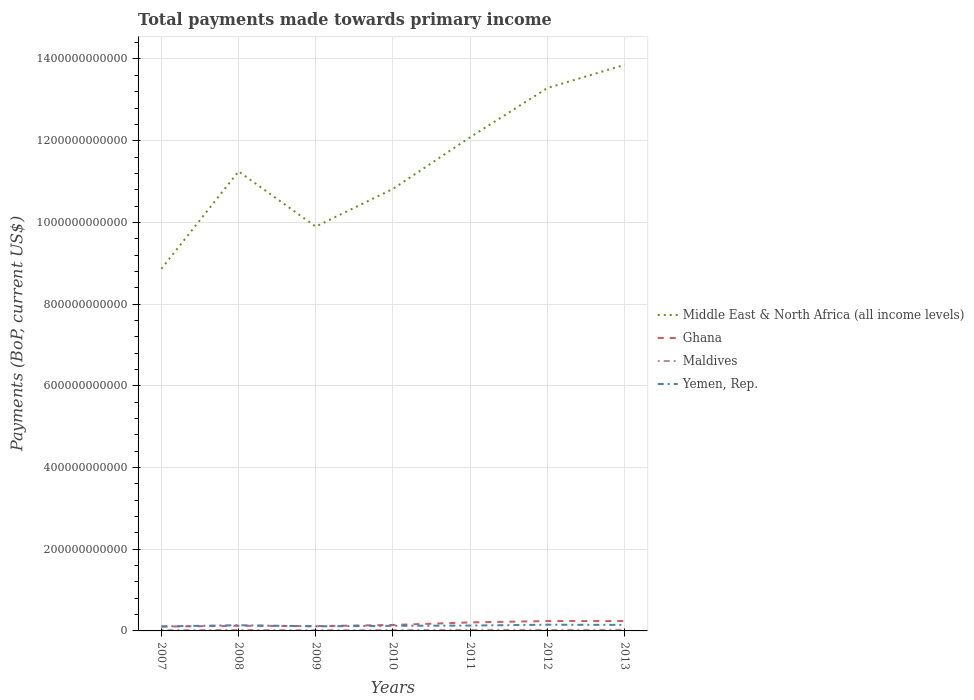How many different coloured lines are there?
Make the answer very short. 4. Across all years, what is the maximum total payments made towards primary income in Middle East & North Africa (all income levels)?
Provide a short and direct response. 8.86e+11. In which year was the total payments made towards primary income in Maldives maximum?
Offer a very short reply. 2009. What is the total total payments made towards primary income in Middle East & North Africa (all income levels) in the graph?
Keep it short and to the point. -9.24e+1. What is the difference between the highest and the second highest total payments made towards primary income in Yemen, Rep.?
Offer a terse response. 4.11e+09. Is the total payments made towards primary income in Maldives strictly greater than the total payments made towards primary income in Ghana over the years?
Your answer should be very brief. Yes. How many lines are there?
Ensure brevity in your answer.  4. What is the difference between two consecutive major ticks on the Y-axis?
Provide a succinct answer. 2.00e+11. Are the values on the major ticks of Y-axis written in scientific E-notation?
Make the answer very short. No. Does the graph contain any zero values?
Offer a very short reply. No. Where does the legend appear in the graph?
Provide a short and direct response. Center right. How many legend labels are there?
Your response must be concise. 4. How are the legend labels stacked?
Offer a very short reply. Vertical. What is the title of the graph?
Provide a succinct answer. Total payments made towards primary income. What is the label or title of the X-axis?
Give a very brief answer. Years. What is the label or title of the Y-axis?
Give a very brief answer. Payments (BoP, current US$). What is the Payments (BoP, current US$) of Middle East & North Africa (all income levels) in 2007?
Offer a terse response. 8.86e+11. What is the Payments (BoP, current US$) of Ghana in 2007?
Your answer should be compact. 1.05e+1. What is the Payments (BoP, current US$) in Maldives in 2007?
Your answer should be very brief. 1.94e+09. What is the Payments (BoP, current US$) of Yemen, Rep. in 2007?
Offer a terse response. 1.11e+1. What is the Payments (BoP, current US$) of Middle East & North Africa (all income levels) in 2008?
Provide a short and direct response. 1.12e+12. What is the Payments (BoP, current US$) of Ghana in 2008?
Your answer should be very brief. 1.27e+1. What is the Payments (BoP, current US$) of Maldives in 2008?
Offer a very short reply. 2.38e+09. What is the Payments (BoP, current US$) in Yemen, Rep. in 2008?
Ensure brevity in your answer.  1.39e+1. What is the Payments (BoP, current US$) in Middle East & North Africa (all income levels) in 2009?
Make the answer very short. 9.90e+11. What is the Payments (BoP, current US$) of Ghana in 2009?
Offer a terse response. 1.17e+1. What is the Payments (BoP, current US$) in Maldives in 2009?
Offer a terse response. 1.76e+09. What is the Payments (BoP, current US$) of Yemen, Rep. in 2009?
Offer a very short reply. 1.13e+1. What is the Payments (BoP, current US$) in Middle East & North Africa (all income levels) in 2010?
Provide a succinct answer. 1.08e+12. What is the Payments (BoP, current US$) of Ghana in 2010?
Your response must be concise. 1.46e+1. What is the Payments (BoP, current US$) of Maldives in 2010?
Offer a terse response. 2.01e+09. What is the Payments (BoP, current US$) of Yemen, Rep. in 2010?
Keep it short and to the point. 1.25e+1. What is the Payments (BoP, current US$) of Middle East & North Africa (all income levels) in 2011?
Your answer should be compact. 1.21e+12. What is the Payments (BoP, current US$) in Ghana in 2011?
Keep it short and to the point. 2.08e+1. What is the Payments (BoP, current US$) in Maldives in 2011?
Give a very brief answer. 2.61e+09. What is the Payments (BoP, current US$) of Yemen, Rep. in 2011?
Make the answer very short. 1.31e+1. What is the Payments (BoP, current US$) in Middle East & North Africa (all income levels) in 2012?
Keep it short and to the point. 1.33e+12. What is the Payments (BoP, current US$) in Ghana in 2012?
Offer a terse response. 2.42e+1. What is the Payments (BoP, current US$) of Maldives in 2012?
Provide a short and direct response. 2.43e+09. What is the Payments (BoP, current US$) of Yemen, Rep. in 2012?
Offer a very short reply. 1.52e+1. What is the Payments (BoP, current US$) of Middle East & North Africa (all income levels) in 2013?
Make the answer very short. 1.39e+12. What is the Payments (BoP, current US$) in Ghana in 2013?
Offer a terse response. 2.41e+1. What is the Payments (BoP, current US$) of Maldives in 2013?
Offer a terse response. 2.77e+09. What is the Payments (BoP, current US$) in Yemen, Rep. in 2013?
Offer a terse response. 1.47e+1. Across all years, what is the maximum Payments (BoP, current US$) in Middle East & North Africa (all income levels)?
Offer a very short reply. 1.39e+12. Across all years, what is the maximum Payments (BoP, current US$) in Ghana?
Ensure brevity in your answer.  2.42e+1. Across all years, what is the maximum Payments (BoP, current US$) of Maldives?
Keep it short and to the point. 2.77e+09. Across all years, what is the maximum Payments (BoP, current US$) in Yemen, Rep.?
Keep it short and to the point. 1.52e+1. Across all years, what is the minimum Payments (BoP, current US$) of Middle East & North Africa (all income levels)?
Make the answer very short. 8.86e+11. Across all years, what is the minimum Payments (BoP, current US$) in Ghana?
Keep it short and to the point. 1.05e+1. Across all years, what is the minimum Payments (BoP, current US$) of Maldives?
Make the answer very short. 1.76e+09. Across all years, what is the minimum Payments (BoP, current US$) in Yemen, Rep.?
Provide a succinct answer. 1.11e+1. What is the total Payments (BoP, current US$) of Middle East & North Africa (all income levels) in the graph?
Offer a very short reply. 8.01e+12. What is the total Payments (BoP, current US$) in Ghana in the graph?
Offer a terse response. 1.19e+11. What is the total Payments (BoP, current US$) in Maldives in the graph?
Provide a short and direct response. 1.59e+1. What is the total Payments (BoP, current US$) of Yemen, Rep. in the graph?
Your answer should be compact. 9.18e+1. What is the difference between the Payments (BoP, current US$) of Middle East & North Africa (all income levels) in 2007 and that in 2008?
Offer a very short reply. -2.38e+11. What is the difference between the Payments (BoP, current US$) in Ghana in 2007 and that in 2008?
Offer a terse response. -2.19e+09. What is the difference between the Payments (BoP, current US$) of Maldives in 2007 and that in 2008?
Keep it short and to the point. -4.38e+08. What is the difference between the Payments (BoP, current US$) of Yemen, Rep. in 2007 and that in 2008?
Ensure brevity in your answer.  -2.83e+09. What is the difference between the Payments (BoP, current US$) of Middle East & North Africa (all income levels) in 2007 and that in 2009?
Make the answer very short. -1.03e+11. What is the difference between the Payments (BoP, current US$) of Ghana in 2007 and that in 2009?
Give a very brief answer. -1.20e+09. What is the difference between the Payments (BoP, current US$) in Maldives in 2007 and that in 2009?
Provide a short and direct response. 1.85e+08. What is the difference between the Payments (BoP, current US$) in Yemen, Rep. in 2007 and that in 2009?
Provide a short and direct response. -1.83e+08. What is the difference between the Payments (BoP, current US$) of Middle East & North Africa (all income levels) in 2007 and that in 2010?
Provide a succinct answer. -1.96e+11. What is the difference between the Payments (BoP, current US$) in Ghana in 2007 and that in 2010?
Offer a very short reply. -4.05e+09. What is the difference between the Payments (BoP, current US$) in Maldives in 2007 and that in 2010?
Your answer should be compact. -6.55e+07. What is the difference between the Payments (BoP, current US$) of Yemen, Rep. in 2007 and that in 2010?
Offer a very short reply. -1.41e+09. What is the difference between the Payments (BoP, current US$) in Middle East & North Africa (all income levels) in 2007 and that in 2011?
Keep it short and to the point. -3.22e+11. What is the difference between the Payments (BoP, current US$) in Ghana in 2007 and that in 2011?
Your response must be concise. -1.03e+1. What is the difference between the Payments (BoP, current US$) in Maldives in 2007 and that in 2011?
Provide a short and direct response. -6.68e+08. What is the difference between the Payments (BoP, current US$) in Yemen, Rep. in 2007 and that in 2011?
Ensure brevity in your answer.  -2.01e+09. What is the difference between the Payments (BoP, current US$) of Middle East & North Africa (all income levels) in 2007 and that in 2012?
Your answer should be very brief. -4.42e+11. What is the difference between the Payments (BoP, current US$) of Ghana in 2007 and that in 2012?
Your response must be concise. -1.37e+1. What is the difference between the Payments (BoP, current US$) in Maldives in 2007 and that in 2012?
Ensure brevity in your answer.  -4.88e+08. What is the difference between the Payments (BoP, current US$) of Yemen, Rep. in 2007 and that in 2012?
Your response must be concise. -4.11e+09. What is the difference between the Payments (BoP, current US$) in Middle East & North Africa (all income levels) in 2007 and that in 2013?
Provide a short and direct response. -4.99e+11. What is the difference between the Payments (BoP, current US$) of Ghana in 2007 and that in 2013?
Give a very brief answer. -1.36e+1. What is the difference between the Payments (BoP, current US$) in Maldives in 2007 and that in 2013?
Keep it short and to the point. -8.25e+08. What is the difference between the Payments (BoP, current US$) in Yemen, Rep. in 2007 and that in 2013?
Keep it short and to the point. -3.65e+09. What is the difference between the Payments (BoP, current US$) of Middle East & North Africa (all income levels) in 2008 and that in 2009?
Your answer should be compact. 1.35e+11. What is the difference between the Payments (BoP, current US$) of Ghana in 2008 and that in 2009?
Your answer should be very brief. 9.85e+08. What is the difference between the Payments (BoP, current US$) of Maldives in 2008 and that in 2009?
Make the answer very short. 6.23e+08. What is the difference between the Payments (BoP, current US$) of Yemen, Rep. in 2008 and that in 2009?
Your answer should be compact. 2.64e+09. What is the difference between the Payments (BoP, current US$) in Middle East & North Africa (all income levels) in 2008 and that in 2010?
Keep it short and to the point. 4.28e+1. What is the difference between the Payments (BoP, current US$) in Ghana in 2008 and that in 2010?
Your answer should be compact. -1.86e+09. What is the difference between the Payments (BoP, current US$) in Maldives in 2008 and that in 2010?
Offer a terse response. 3.72e+08. What is the difference between the Payments (BoP, current US$) of Yemen, Rep. in 2008 and that in 2010?
Your response must be concise. 1.42e+09. What is the difference between the Payments (BoP, current US$) of Middle East & North Africa (all income levels) in 2008 and that in 2011?
Provide a succinct answer. -8.36e+1. What is the difference between the Payments (BoP, current US$) of Ghana in 2008 and that in 2011?
Make the answer very short. -8.12e+09. What is the difference between the Payments (BoP, current US$) in Maldives in 2008 and that in 2011?
Give a very brief answer. -2.30e+08. What is the difference between the Payments (BoP, current US$) of Yemen, Rep. in 2008 and that in 2011?
Ensure brevity in your answer.  8.20e+08. What is the difference between the Payments (BoP, current US$) of Middle East & North Africa (all income levels) in 2008 and that in 2012?
Your answer should be very brief. -2.04e+11. What is the difference between the Payments (BoP, current US$) of Ghana in 2008 and that in 2012?
Offer a terse response. -1.15e+1. What is the difference between the Payments (BoP, current US$) of Maldives in 2008 and that in 2012?
Offer a very short reply. -4.98e+07. What is the difference between the Payments (BoP, current US$) of Yemen, Rep. in 2008 and that in 2012?
Provide a succinct answer. -1.29e+09. What is the difference between the Payments (BoP, current US$) in Middle East & North Africa (all income levels) in 2008 and that in 2013?
Your answer should be compact. -2.61e+11. What is the difference between the Payments (BoP, current US$) of Ghana in 2008 and that in 2013?
Your answer should be very brief. -1.14e+1. What is the difference between the Payments (BoP, current US$) in Maldives in 2008 and that in 2013?
Your answer should be very brief. -3.87e+08. What is the difference between the Payments (BoP, current US$) of Yemen, Rep. in 2008 and that in 2013?
Provide a short and direct response. -8.29e+08. What is the difference between the Payments (BoP, current US$) in Middle East & North Africa (all income levels) in 2009 and that in 2010?
Offer a terse response. -9.24e+1. What is the difference between the Payments (BoP, current US$) in Ghana in 2009 and that in 2010?
Ensure brevity in your answer.  -2.85e+09. What is the difference between the Payments (BoP, current US$) in Maldives in 2009 and that in 2010?
Give a very brief answer. -2.50e+08. What is the difference between the Payments (BoP, current US$) of Yemen, Rep. in 2009 and that in 2010?
Provide a short and direct response. -1.23e+09. What is the difference between the Payments (BoP, current US$) in Middle East & North Africa (all income levels) in 2009 and that in 2011?
Give a very brief answer. -2.19e+11. What is the difference between the Payments (BoP, current US$) in Ghana in 2009 and that in 2011?
Provide a succinct answer. -9.10e+09. What is the difference between the Payments (BoP, current US$) in Maldives in 2009 and that in 2011?
Make the answer very short. -8.52e+08. What is the difference between the Payments (BoP, current US$) in Yemen, Rep. in 2009 and that in 2011?
Keep it short and to the point. -1.82e+09. What is the difference between the Payments (BoP, current US$) of Middle East & North Africa (all income levels) in 2009 and that in 2012?
Provide a succinct answer. -3.39e+11. What is the difference between the Payments (BoP, current US$) of Ghana in 2009 and that in 2012?
Keep it short and to the point. -1.25e+1. What is the difference between the Payments (BoP, current US$) in Maldives in 2009 and that in 2012?
Make the answer very short. -6.72e+08. What is the difference between the Payments (BoP, current US$) of Yemen, Rep. in 2009 and that in 2012?
Provide a succinct answer. -3.93e+09. What is the difference between the Payments (BoP, current US$) in Middle East & North Africa (all income levels) in 2009 and that in 2013?
Keep it short and to the point. -3.96e+11. What is the difference between the Payments (BoP, current US$) of Ghana in 2009 and that in 2013?
Provide a short and direct response. -1.24e+1. What is the difference between the Payments (BoP, current US$) in Maldives in 2009 and that in 2013?
Your answer should be very brief. -1.01e+09. What is the difference between the Payments (BoP, current US$) of Yemen, Rep. in 2009 and that in 2013?
Offer a very short reply. -3.47e+09. What is the difference between the Payments (BoP, current US$) of Middle East & North Africa (all income levels) in 2010 and that in 2011?
Your answer should be very brief. -1.26e+11. What is the difference between the Payments (BoP, current US$) of Ghana in 2010 and that in 2011?
Make the answer very short. -6.25e+09. What is the difference between the Payments (BoP, current US$) in Maldives in 2010 and that in 2011?
Keep it short and to the point. -6.02e+08. What is the difference between the Payments (BoP, current US$) of Yemen, Rep. in 2010 and that in 2011?
Provide a succinct answer. -5.96e+08. What is the difference between the Payments (BoP, current US$) in Middle East & North Africa (all income levels) in 2010 and that in 2012?
Keep it short and to the point. -2.47e+11. What is the difference between the Payments (BoP, current US$) in Ghana in 2010 and that in 2012?
Make the answer very short. -9.63e+09. What is the difference between the Payments (BoP, current US$) of Maldives in 2010 and that in 2012?
Provide a short and direct response. -4.22e+08. What is the difference between the Payments (BoP, current US$) in Yemen, Rep. in 2010 and that in 2012?
Provide a succinct answer. -2.70e+09. What is the difference between the Payments (BoP, current US$) of Middle East & North Africa (all income levels) in 2010 and that in 2013?
Provide a short and direct response. -3.04e+11. What is the difference between the Payments (BoP, current US$) in Ghana in 2010 and that in 2013?
Provide a succinct answer. -9.57e+09. What is the difference between the Payments (BoP, current US$) in Maldives in 2010 and that in 2013?
Offer a terse response. -7.59e+08. What is the difference between the Payments (BoP, current US$) in Yemen, Rep. in 2010 and that in 2013?
Ensure brevity in your answer.  -2.24e+09. What is the difference between the Payments (BoP, current US$) in Middle East & North Africa (all income levels) in 2011 and that in 2012?
Give a very brief answer. -1.20e+11. What is the difference between the Payments (BoP, current US$) of Ghana in 2011 and that in 2012?
Your response must be concise. -3.37e+09. What is the difference between the Payments (BoP, current US$) of Maldives in 2011 and that in 2012?
Provide a succinct answer. 1.80e+08. What is the difference between the Payments (BoP, current US$) in Yemen, Rep. in 2011 and that in 2012?
Provide a short and direct response. -2.11e+09. What is the difference between the Payments (BoP, current US$) of Middle East & North Africa (all income levels) in 2011 and that in 2013?
Give a very brief answer. -1.77e+11. What is the difference between the Payments (BoP, current US$) of Ghana in 2011 and that in 2013?
Offer a very short reply. -3.32e+09. What is the difference between the Payments (BoP, current US$) in Maldives in 2011 and that in 2013?
Your response must be concise. -1.57e+08. What is the difference between the Payments (BoP, current US$) of Yemen, Rep. in 2011 and that in 2013?
Ensure brevity in your answer.  -1.65e+09. What is the difference between the Payments (BoP, current US$) in Middle East & North Africa (all income levels) in 2012 and that in 2013?
Provide a succinct answer. -5.67e+1. What is the difference between the Payments (BoP, current US$) of Ghana in 2012 and that in 2013?
Provide a succinct answer. 5.29e+07. What is the difference between the Payments (BoP, current US$) in Maldives in 2012 and that in 2013?
Your response must be concise. -3.37e+08. What is the difference between the Payments (BoP, current US$) of Yemen, Rep. in 2012 and that in 2013?
Ensure brevity in your answer.  4.59e+08. What is the difference between the Payments (BoP, current US$) of Middle East & North Africa (all income levels) in 2007 and the Payments (BoP, current US$) of Ghana in 2008?
Ensure brevity in your answer.  8.74e+11. What is the difference between the Payments (BoP, current US$) in Middle East & North Africa (all income levels) in 2007 and the Payments (BoP, current US$) in Maldives in 2008?
Your answer should be compact. 8.84e+11. What is the difference between the Payments (BoP, current US$) in Middle East & North Africa (all income levels) in 2007 and the Payments (BoP, current US$) in Yemen, Rep. in 2008?
Your answer should be very brief. 8.73e+11. What is the difference between the Payments (BoP, current US$) in Ghana in 2007 and the Payments (BoP, current US$) in Maldives in 2008?
Provide a short and direct response. 8.13e+09. What is the difference between the Payments (BoP, current US$) in Ghana in 2007 and the Payments (BoP, current US$) in Yemen, Rep. in 2008?
Provide a succinct answer. -3.41e+09. What is the difference between the Payments (BoP, current US$) in Maldives in 2007 and the Payments (BoP, current US$) in Yemen, Rep. in 2008?
Your answer should be compact. -1.20e+1. What is the difference between the Payments (BoP, current US$) of Middle East & North Africa (all income levels) in 2007 and the Payments (BoP, current US$) of Ghana in 2009?
Make the answer very short. 8.75e+11. What is the difference between the Payments (BoP, current US$) of Middle East & North Africa (all income levels) in 2007 and the Payments (BoP, current US$) of Maldives in 2009?
Provide a succinct answer. 8.85e+11. What is the difference between the Payments (BoP, current US$) in Middle East & North Africa (all income levels) in 2007 and the Payments (BoP, current US$) in Yemen, Rep. in 2009?
Offer a terse response. 8.75e+11. What is the difference between the Payments (BoP, current US$) of Ghana in 2007 and the Payments (BoP, current US$) of Maldives in 2009?
Provide a succinct answer. 8.75e+09. What is the difference between the Payments (BoP, current US$) of Ghana in 2007 and the Payments (BoP, current US$) of Yemen, Rep. in 2009?
Give a very brief answer. -7.66e+08. What is the difference between the Payments (BoP, current US$) in Maldives in 2007 and the Payments (BoP, current US$) in Yemen, Rep. in 2009?
Your response must be concise. -9.33e+09. What is the difference between the Payments (BoP, current US$) in Middle East & North Africa (all income levels) in 2007 and the Payments (BoP, current US$) in Ghana in 2010?
Give a very brief answer. 8.72e+11. What is the difference between the Payments (BoP, current US$) of Middle East & North Africa (all income levels) in 2007 and the Payments (BoP, current US$) of Maldives in 2010?
Give a very brief answer. 8.84e+11. What is the difference between the Payments (BoP, current US$) in Middle East & North Africa (all income levels) in 2007 and the Payments (BoP, current US$) in Yemen, Rep. in 2010?
Your answer should be compact. 8.74e+11. What is the difference between the Payments (BoP, current US$) of Ghana in 2007 and the Payments (BoP, current US$) of Maldives in 2010?
Offer a very short reply. 8.50e+09. What is the difference between the Payments (BoP, current US$) in Ghana in 2007 and the Payments (BoP, current US$) in Yemen, Rep. in 2010?
Give a very brief answer. -1.99e+09. What is the difference between the Payments (BoP, current US$) in Maldives in 2007 and the Payments (BoP, current US$) in Yemen, Rep. in 2010?
Provide a succinct answer. -1.06e+1. What is the difference between the Payments (BoP, current US$) of Middle East & North Africa (all income levels) in 2007 and the Payments (BoP, current US$) of Ghana in 2011?
Your answer should be very brief. 8.66e+11. What is the difference between the Payments (BoP, current US$) in Middle East & North Africa (all income levels) in 2007 and the Payments (BoP, current US$) in Maldives in 2011?
Offer a terse response. 8.84e+11. What is the difference between the Payments (BoP, current US$) of Middle East & North Africa (all income levels) in 2007 and the Payments (BoP, current US$) of Yemen, Rep. in 2011?
Ensure brevity in your answer.  8.73e+11. What is the difference between the Payments (BoP, current US$) in Ghana in 2007 and the Payments (BoP, current US$) in Maldives in 2011?
Your answer should be very brief. 7.90e+09. What is the difference between the Payments (BoP, current US$) of Ghana in 2007 and the Payments (BoP, current US$) of Yemen, Rep. in 2011?
Offer a very short reply. -2.59e+09. What is the difference between the Payments (BoP, current US$) of Maldives in 2007 and the Payments (BoP, current US$) of Yemen, Rep. in 2011?
Offer a very short reply. -1.12e+1. What is the difference between the Payments (BoP, current US$) of Middle East & North Africa (all income levels) in 2007 and the Payments (BoP, current US$) of Ghana in 2012?
Your answer should be compact. 8.62e+11. What is the difference between the Payments (BoP, current US$) of Middle East & North Africa (all income levels) in 2007 and the Payments (BoP, current US$) of Maldives in 2012?
Ensure brevity in your answer.  8.84e+11. What is the difference between the Payments (BoP, current US$) in Middle East & North Africa (all income levels) in 2007 and the Payments (BoP, current US$) in Yemen, Rep. in 2012?
Offer a very short reply. 8.71e+11. What is the difference between the Payments (BoP, current US$) in Ghana in 2007 and the Payments (BoP, current US$) in Maldives in 2012?
Keep it short and to the point. 8.08e+09. What is the difference between the Payments (BoP, current US$) of Ghana in 2007 and the Payments (BoP, current US$) of Yemen, Rep. in 2012?
Make the answer very short. -4.70e+09. What is the difference between the Payments (BoP, current US$) in Maldives in 2007 and the Payments (BoP, current US$) in Yemen, Rep. in 2012?
Provide a succinct answer. -1.33e+1. What is the difference between the Payments (BoP, current US$) in Middle East & North Africa (all income levels) in 2007 and the Payments (BoP, current US$) in Ghana in 2013?
Provide a short and direct response. 8.62e+11. What is the difference between the Payments (BoP, current US$) of Middle East & North Africa (all income levels) in 2007 and the Payments (BoP, current US$) of Maldives in 2013?
Give a very brief answer. 8.84e+11. What is the difference between the Payments (BoP, current US$) of Middle East & North Africa (all income levels) in 2007 and the Payments (BoP, current US$) of Yemen, Rep. in 2013?
Your response must be concise. 8.72e+11. What is the difference between the Payments (BoP, current US$) of Ghana in 2007 and the Payments (BoP, current US$) of Maldives in 2013?
Offer a terse response. 7.74e+09. What is the difference between the Payments (BoP, current US$) in Ghana in 2007 and the Payments (BoP, current US$) in Yemen, Rep. in 2013?
Provide a short and direct response. -4.24e+09. What is the difference between the Payments (BoP, current US$) in Maldives in 2007 and the Payments (BoP, current US$) in Yemen, Rep. in 2013?
Offer a very short reply. -1.28e+1. What is the difference between the Payments (BoP, current US$) in Middle East & North Africa (all income levels) in 2008 and the Payments (BoP, current US$) in Ghana in 2009?
Offer a very short reply. 1.11e+12. What is the difference between the Payments (BoP, current US$) of Middle East & North Africa (all income levels) in 2008 and the Payments (BoP, current US$) of Maldives in 2009?
Your answer should be compact. 1.12e+12. What is the difference between the Payments (BoP, current US$) in Middle East & North Africa (all income levels) in 2008 and the Payments (BoP, current US$) in Yemen, Rep. in 2009?
Give a very brief answer. 1.11e+12. What is the difference between the Payments (BoP, current US$) of Ghana in 2008 and the Payments (BoP, current US$) of Maldives in 2009?
Your response must be concise. 1.09e+1. What is the difference between the Payments (BoP, current US$) of Ghana in 2008 and the Payments (BoP, current US$) of Yemen, Rep. in 2009?
Make the answer very short. 1.42e+09. What is the difference between the Payments (BoP, current US$) in Maldives in 2008 and the Payments (BoP, current US$) in Yemen, Rep. in 2009?
Provide a short and direct response. -8.89e+09. What is the difference between the Payments (BoP, current US$) of Middle East & North Africa (all income levels) in 2008 and the Payments (BoP, current US$) of Ghana in 2010?
Provide a succinct answer. 1.11e+12. What is the difference between the Payments (BoP, current US$) of Middle East & North Africa (all income levels) in 2008 and the Payments (BoP, current US$) of Maldives in 2010?
Provide a short and direct response. 1.12e+12. What is the difference between the Payments (BoP, current US$) in Middle East & North Africa (all income levels) in 2008 and the Payments (BoP, current US$) in Yemen, Rep. in 2010?
Keep it short and to the point. 1.11e+12. What is the difference between the Payments (BoP, current US$) in Ghana in 2008 and the Payments (BoP, current US$) in Maldives in 2010?
Your answer should be very brief. 1.07e+1. What is the difference between the Payments (BoP, current US$) of Ghana in 2008 and the Payments (BoP, current US$) of Yemen, Rep. in 2010?
Your response must be concise. 1.93e+08. What is the difference between the Payments (BoP, current US$) of Maldives in 2008 and the Payments (BoP, current US$) of Yemen, Rep. in 2010?
Make the answer very short. -1.01e+1. What is the difference between the Payments (BoP, current US$) of Middle East & North Africa (all income levels) in 2008 and the Payments (BoP, current US$) of Ghana in 2011?
Give a very brief answer. 1.10e+12. What is the difference between the Payments (BoP, current US$) of Middle East & North Africa (all income levels) in 2008 and the Payments (BoP, current US$) of Maldives in 2011?
Offer a terse response. 1.12e+12. What is the difference between the Payments (BoP, current US$) in Middle East & North Africa (all income levels) in 2008 and the Payments (BoP, current US$) in Yemen, Rep. in 2011?
Provide a short and direct response. 1.11e+12. What is the difference between the Payments (BoP, current US$) in Ghana in 2008 and the Payments (BoP, current US$) in Maldives in 2011?
Offer a terse response. 1.01e+1. What is the difference between the Payments (BoP, current US$) of Ghana in 2008 and the Payments (BoP, current US$) of Yemen, Rep. in 2011?
Provide a short and direct response. -4.03e+08. What is the difference between the Payments (BoP, current US$) of Maldives in 2008 and the Payments (BoP, current US$) of Yemen, Rep. in 2011?
Keep it short and to the point. -1.07e+1. What is the difference between the Payments (BoP, current US$) in Middle East & North Africa (all income levels) in 2008 and the Payments (BoP, current US$) in Ghana in 2012?
Offer a terse response. 1.10e+12. What is the difference between the Payments (BoP, current US$) in Middle East & North Africa (all income levels) in 2008 and the Payments (BoP, current US$) in Maldives in 2012?
Your response must be concise. 1.12e+12. What is the difference between the Payments (BoP, current US$) in Middle East & North Africa (all income levels) in 2008 and the Payments (BoP, current US$) in Yemen, Rep. in 2012?
Offer a very short reply. 1.11e+12. What is the difference between the Payments (BoP, current US$) of Ghana in 2008 and the Payments (BoP, current US$) of Maldives in 2012?
Your response must be concise. 1.03e+1. What is the difference between the Payments (BoP, current US$) of Ghana in 2008 and the Payments (BoP, current US$) of Yemen, Rep. in 2012?
Offer a terse response. -2.51e+09. What is the difference between the Payments (BoP, current US$) of Maldives in 2008 and the Payments (BoP, current US$) of Yemen, Rep. in 2012?
Ensure brevity in your answer.  -1.28e+1. What is the difference between the Payments (BoP, current US$) of Middle East & North Africa (all income levels) in 2008 and the Payments (BoP, current US$) of Ghana in 2013?
Offer a terse response. 1.10e+12. What is the difference between the Payments (BoP, current US$) in Middle East & North Africa (all income levels) in 2008 and the Payments (BoP, current US$) in Maldives in 2013?
Provide a succinct answer. 1.12e+12. What is the difference between the Payments (BoP, current US$) in Middle East & North Africa (all income levels) in 2008 and the Payments (BoP, current US$) in Yemen, Rep. in 2013?
Give a very brief answer. 1.11e+12. What is the difference between the Payments (BoP, current US$) in Ghana in 2008 and the Payments (BoP, current US$) in Maldives in 2013?
Provide a short and direct response. 9.93e+09. What is the difference between the Payments (BoP, current US$) of Ghana in 2008 and the Payments (BoP, current US$) of Yemen, Rep. in 2013?
Give a very brief answer. -2.05e+09. What is the difference between the Payments (BoP, current US$) of Maldives in 2008 and the Payments (BoP, current US$) of Yemen, Rep. in 2013?
Provide a short and direct response. -1.24e+1. What is the difference between the Payments (BoP, current US$) in Middle East & North Africa (all income levels) in 2009 and the Payments (BoP, current US$) in Ghana in 2010?
Provide a short and direct response. 9.75e+11. What is the difference between the Payments (BoP, current US$) in Middle East & North Africa (all income levels) in 2009 and the Payments (BoP, current US$) in Maldives in 2010?
Offer a terse response. 9.88e+11. What is the difference between the Payments (BoP, current US$) of Middle East & North Africa (all income levels) in 2009 and the Payments (BoP, current US$) of Yemen, Rep. in 2010?
Give a very brief answer. 9.77e+11. What is the difference between the Payments (BoP, current US$) of Ghana in 2009 and the Payments (BoP, current US$) of Maldives in 2010?
Give a very brief answer. 9.70e+09. What is the difference between the Payments (BoP, current US$) in Ghana in 2009 and the Payments (BoP, current US$) in Yemen, Rep. in 2010?
Your response must be concise. -7.93e+08. What is the difference between the Payments (BoP, current US$) of Maldives in 2009 and the Payments (BoP, current US$) of Yemen, Rep. in 2010?
Give a very brief answer. -1.07e+1. What is the difference between the Payments (BoP, current US$) in Middle East & North Africa (all income levels) in 2009 and the Payments (BoP, current US$) in Ghana in 2011?
Offer a very short reply. 9.69e+11. What is the difference between the Payments (BoP, current US$) of Middle East & North Africa (all income levels) in 2009 and the Payments (BoP, current US$) of Maldives in 2011?
Offer a terse response. 9.87e+11. What is the difference between the Payments (BoP, current US$) in Middle East & North Africa (all income levels) in 2009 and the Payments (BoP, current US$) in Yemen, Rep. in 2011?
Your response must be concise. 9.77e+11. What is the difference between the Payments (BoP, current US$) in Ghana in 2009 and the Payments (BoP, current US$) in Maldives in 2011?
Make the answer very short. 9.10e+09. What is the difference between the Payments (BoP, current US$) in Ghana in 2009 and the Payments (BoP, current US$) in Yemen, Rep. in 2011?
Offer a terse response. -1.39e+09. What is the difference between the Payments (BoP, current US$) of Maldives in 2009 and the Payments (BoP, current US$) of Yemen, Rep. in 2011?
Give a very brief answer. -1.13e+1. What is the difference between the Payments (BoP, current US$) in Middle East & North Africa (all income levels) in 2009 and the Payments (BoP, current US$) in Ghana in 2012?
Give a very brief answer. 9.66e+11. What is the difference between the Payments (BoP, current US$) in Middle East & North Africa (all income levels) in 2009 and the Payments (BoP, current US$) in Maldives in 2012?
Offer a terse response. 9.87e+11. What is the difference between the Payments (BoP, current US$) of Middle East & North Africa (all income levels) in 2009 and the Payments (BoP, current US$) of Yemen, Rep. in 2012?
Provide a succinct answer. 9.75e+11. What is the difference between the Payments (BoP, current US$) in Ghana in 2009 and the Payments (BoP, current US$) in Maldives in 2012?
Your answer should be compact. 9.28e+09. What is the difference between the Payments (BoP, current US$) in Ghana in 2009 and the Payments (BoP, current US$) in Yemen, Rep. in 2012?
Provide a short and direct response. -3.50e+09. What is the difference between the Payments (BoP, current US$) of Maldives in 2009 and the Payments (BoP, current US$) of Yemen, Rep. in 2012?
Offer a terse response. -1.34e+1. What is the difference between the Payments (BoP, current US$) of Middle East & North Africa (all income levels) in 2009 and the Payments (BoP, current US$) of Ghana in 2013?
Provide a succinct answer. 9.66e+11. What is the difference between the Payments (BoP, current US$) in Middle East & North Africa (all income levels) in 2009 and the Payments (BoP, current US$) in Maldives in 2013?
Give a very brief answer. 9.87e+11. What is the difference between the Payments (BoP, current US$) in Middle East & North Africa (all income levels) in 2009 and the Payments (BoP, current US$) in Yemen, Rep. in 2013?
Make the answer very short. 9.75e+11. What is the difference between the Payments (BoP, current US$) in Ghana in 2009 and the Payments (BoP, current US$) in Maldives in 2013?
Your answer should be compact. 8.94e+09. What is the difference between the Payments (BoP, current US$) in Ghana in 2009 and the Payments (BoP, current US$) in Yemen, Rep. in 2013?
Give a very brief answer. -3.04e+09. What is the difference between the Payments (BoP, current US$) in Maldives in 2009 and the Payments (BoP, current US$) in Yemen, Rep. in 2013?
Provide a succinct answer. -1.30e+1. What is the difference between the Payments (BoP, current US$) in Middle East & North Africa (all income levels) in 2010 and the Payments (BoP, current US$) in Ghana in 2011?
Keep it short and to the point. 1.06e+12. What is the difference between the Payments (BoP, current US$) of Middle East & North Africa (all income levels) in 2010 and the Payments (BoP, current US$) of Maldives in 2011?
Keep it short and to the point. 1.08e+12. What is the difference between the Payments (BoP, current US$) in Middle East & North Africa (all income levels) in 2010 and the Payments (BoP, current US$) in Yemen, Rep. in 2011?
Your answer should be very brief. 1.07e+12. What is the difference between the Payments (BoP, current US$) in Ghana in 2010 and the Payments (BoP, current US$) in Maldives in 2011?
Your response must be concise. 1.19e+1. What is the difference between the Payments (BoP, current US$) of Ghana in 2010 and the Payments (BoP, current US$) of Yemen, Rep. in 2011?
Your answer should be compact. 1.46e+09. What is the difference between the Payments (BoP, current US$) in Maldives in 2010 and the Payments (BoP, current US$) in Yemen, Rep. in 2011?
Provide a short and direct response. -1.11e+1. What is the difference between the Payments (BoP, current US$) of Middle East & North Africa (all income levels) in 2010 and the Payments (BoP, current US$) of Ghana in 2012?
Keep it short and to the point. 1.06e+12. What is the difference between the Payments (BoP, current US$) of Middle East & North Africa (all income levels) in 2010 and the Payments (BoP, current US$) of Maldives in 2012?
Offer a terse response. 1.08e+12. What is the difference between the Payments (BoP, current US$) in Middle East & North Africa (all income levels) in 2010 and the Payments (BoP, current US$) in Yemen, Rep. in 2012?
Your answer should be very brief. 1.07e+12. What is the difference between the Payments (BoP, current US$) of Ghana in 2010 and the Payments (BoP, current US$) of Maldives in 2012?
Make the answer very short. 1.21e+1. What is the difference between the Payments (BoP, current US$) of Ghana in 2010 and the Payments (BoP, current US$) of Yemen, Rep. in 2012?
Make the answer very short. -6.46e+08. What is the difference between the Payments (BoP, current US$) of Maldives in 2010 and the Payments (BoP, current US$) of Yemen, Rep. in 2012?
Your answer should be compact. -1.32e+1. What is the difference between the Payments (BoP, current US$) of Middle East & North Africa (all income levels) in 2010 and the Payments (BoP, current US$) of Ghana in 2013?
Make the answer very short. 1.06e+12. What is the difference between the Payments (BoP, current US$) of Middle East & North Africa (all income levels) in 2010 and the Payments (BoP, current US$) of Maldives in 2013?
Provide a succinct answer. 1.08e+12. What is the difference between the Payments (BoP, current US$) of Middle East & North Africa (all income levels) in 2010 and the Payments (BoP, current US$) of Yemen, Rep. in 2013?
Keep it short and to the point. 1.07e+12. What is the difference between the Payments (BoP, current US$) in Ghana in 2010 and the Payments (BoP, current US$) in Maldives in 2013?
Ensure brevity in your answer.  1.18e+1. What is the difference between the Payments (BoP, current US$) in Ghana in 2010 and the Payments (BoP, current US$) in Yemen, Rep. in 2013?
Provide a succinct answer. -1.87e+08. What is the difference between the Payments (BoP, current US$) of Maldives in 2010 and the Payments (BoP, current US$) of Yemen, Rep. in 2013?
Make the answer very short. -1.27e+1. What is the difference between the Payments (BoP, current US$) in Middle East & North Africa (all income levels) in 2011 and the Payments (BoP, current US$) in Ghana in 2012?
Offer a very short reply. 1.18e+12. What is the difference between the Payments (BoP, current US$) in Middle East & North Africa (all income levels) in 2011 and the Payments (BoP, current US$) in Maldives in 2012?
Ensure brevity in your answer.  1.21e+12. What is the difference between the Payments (BoP, current US$) in Middle East & North Africa (all income levels) in 2011 and the Payments (BoP, current US$) in Yemen, Rep. in 2012?
Provide a succinct answer. 1.19e+12. What is the difference between the Payments (BoP, current US$) in Ghana in 2011 and the Payments (BoP, current US$) in Maldives in 2012?
Give a very brief answer. 1.84e+1. What is the difference between the Payments (BoP, current US$) of Ghana in 2011 and the Payments (BoP, current US$) of Yemen, Rep. in 2012?
Keep it short and to the point. 5.61e+09. What is the difference between the Payments (BoP, current US$) of Maldives in 2011 and the Payments (BoP, current US$) of Yemen, Rep. in 2012?
Offer a terse response. -1.26e+1. What is the difference between the Payments (BoP, current US$) of Middle East & North Africa (all income levels) in 2011 and the Payments (BoP, current US$) of Ghana in 2013?
Offer a very short reply. 1.18e+12. What is the difference between the Payments (BoP, current US$) in Middle East & North Africa (all income levels) in 2011 and the Payments (BoP, current US$) in Maldives in 2013?
Your response must be concise. 1.21e+12. What is the difference between the Payments (BoP, current US$) of Middle East & North Africa (all income levels) in 2011 and the Payments (BoP, current US$) of Yemen, Rep. in 2013?
Offer a terse response. 1.19e+12. What is the difference between the Payments (BoP, current US$) of Ghana in 2011 and the Payments (BoP, current US$) of Maldives in 2013?
Your answer should be very brief. 1.80e+1. What is the difference between the Payments (BoP, current US$) in Ghana in 2011 and the Payments (BoP, current US$) in Yemen, Rep. in 2013?
Your answer should be compact. 6.07e+09. What is the difference between the Payments (BoP, current US$) in Maldives in 2011 and the Payments (BoP, current US$) in Yemen, Rep. in 2013?
Offer a terse response. -1.21e+1. What is the difference between the Payments (BoP, current US$) of Middle East & North Africa (all income levels) in 2012 and the Payments (BoP, current US$) of Ghana in 2013?
Your response must be concise. 1.30e+12. What is the difference between the Payments (BoP, current US$) of Middle East & North Africa (all income levels) in 2012 and the Payments (BoP, current US$) of Maldives in 2013?
Provide a short and direct response. 1.33e+12. What is the difference between the Payments (BoP, current US$) in Middle East & North Africa (all income levels) in 2012 and the Payments (BoP, current US$) in Yemen, Rep. in 2013?
Offer a very short reply. 1.31e+12. What is the difference between the Payments (BoP, current US$) of Ghana in 2012 and the Payments (BoP, current US$) of Maldives in 2013?
Your answer should be compact. 2.14e+1. What is the difference between the Payments (BoP, current US$) in Ghana in 2012 and the Payments (BoP, current US$) in Yemen, Rep. in 2013?
Offer a terse response. 9.44e+09. What is the difference between the Payments (BoP, current US$) of Maldives in 2012 and the Payments (BoP, current US$) of Yemen, Rep. in 2013?
Offer a very short reply. -1.23e+1. What is the average Payments (BoP, current US$) of Middle East & North Africa (all income levels) per year?
Offer a terse response. 1.14e+12. What is the average Payments (BoP, current US$) of Ghana per year?
Keep it short and to the point. 1.69e+1. What is the average Payments (BoP, current US$) of Maldives per year?
Make the answer very short. 2.27e+09. What is the average Payments (BoP, current US$) in Yemen, Rep. per year?
Provide a succinct answer. 1.31e+1. In the year 2007, what is the difference between the Payments (BoP, current US$) in Middle East & North Africa (all income levels) and Payments (BoP, current US$) in Ghana?
Give a very brief answer. 8.76e+11. In the year 2007, what is the difference between the Payments (BoP, current US$) of Middle East & North Africa (all income levels) and Payments (BoP, current US$) of Maldives?
Your answer should be compact. 8.85e+11. In the year 2007, what is the difference between the Payments (BoP, current US$) in Middle East & North Africa (all income levels) and Payments (BoP, current US$) in Yemen, Rep.?
Provide a short and direct response. 8.75e+11. In the year 2007, what is the difference between the Payments (BoP, current US$) in Ghana and Payments (BoP, current US$) in Maldives?
Your answer should be compact. 8.57e+09. In the year 2007, what is the difference between the Payments (BoP, current US$) in Ghana and Payments (BoP, current US$) in Yemen, Rep.?
Keep it short and to the point. -5.83e+08. In the year 2007, what is the difference between the Payments (BoP, current US$) of Maldives and Payments (BoP, current US$) of Yemen, Rep.?
Offer a very short reply. -9.15e+09. In the year 2008, what is the difference between the Payments (BoP, current US$) in Middle East & North Africa (all income levels) and Payments (BoP, current US$) in Ghana?
Make the answer very short. 1.11e+12. In the year 2008, what is the difference between the Payments (BoP, current US$) of Middle East & North Africa (all income levels) and Payments (BoP, current US$) of Maldives?
Give a very brief answer. 1.12e+12. In the year 2008, what is the difference between the Payments (BoP, current US$) in Middle East & North Africa (all income levels) and Payments (BoP, current US$) in Yemen, Rep.?
Ensure brevity in your answer.  1.11e+12. In the year 2008, what is the difference between the Payments (BoP, current US$) in Ghana and Payments (BoP, current US$) in Maldives?
Your answer should be compact. 1.03e+1. In the year 2008, what is the difference between the Payments (BoP, current US$) of Ghana and Payments (BoP, current US$) of Yemen, Rep.?
Offer a very short reply. -1.22e+09. In the year 2008, what is the difference between the Payments (BoP, current US$) in Maldives and Payments (BoP, current US$) in Yemen, Rep.?
Make the answer very short. -1.15e+1. In the year 2009, what is the difference between the Payments (BoP, current US$) in Middle East & North Africa (all income levels) and Payments (BoP, current US$) in Ghana?
Offer a terse response. 9.78e+11. In the year 2009, what is the difference between the Payments (BoP, current US$) in Middle East & North Africa (all income levels) and Payments (BoP, current US$) in Maldives?
Offer a very short reply. 9.88e+11. In the year 2009, what is the difference between the Payments (BoP, current US$) in Middle East & North Africa (all income levels) and Payments (BoP, current US$) in Yemen, Rep.?
Ensure brevity in your answer.  9.78e+11. In the year 2009, what is the difference between the Payments (BoP, current US$) in Ghana and Payments (BoP, current US$) in Maldives?
Give a very brief answer. 9.95e+09. In the year 2009, what is the difference between the Payments (BoP, current US$) of Ghana and Payments (BoP, current US$) of Yemen, Rep.?
Offer a very short reply. 4.34e+08. In the year 2009, what is the difference between the Payments (BoP, current US$) of Maldives and Payments (BoP, current US$) of Yemen, Rep.?
Make the answer very short. -9.52e+09. In the year 2010, what is the difference between the Payments (BoP, current US$) of Middle East & North Africa (all income levels) and Payments (BoP, current US$) of Ghana?
Make the answer very short. 1.07e+12. In the year 2010, what is the difference between the Payments (BoP, current US$) in Middle East & North Africa (all income levels) and Payments (BoP, current US$) in Maldives?
Provide a short and direct response. 1.08e+12. In the year 2010, what is the difference between the Payments (BoP, current US$) in Middle East & North Africa (all income levels) and Payments (BoP, current US$) in Yemen, Rep.?
Provide a short and direct response. 1.07e+12. In the year 2010, what is the difference between the Payments (BoP, current US$) in Ghana and Payments (BoP, current US$) in Maldives?
Provide a succinct answer. 1.26e+1. In the year 2010, what is the difference between the Payments (BoP, current US$) of Ghana and Payments (BoP, current US$) of Yemen, Rep.?
Provide a succinct answer. 2.06e+09. In the year 2010, what is the difference between the Payments (BoP, current US$) in Maldives and Payments (BoP, current US$) in Yemen, Rep.?
Give a very brief answer. -1.05e+1. In the year 2011, what is the difference between the Payments (BoP, current US$) in Middle East & North Africa (all income levels) and Payments (BoP, current US$) in Ghana?
Offer a very short reply. 1.19e+12. In the year 2011, what is the difference between the Payments (BoP, current US$) in Middle East & North Africa (all income levels) and Payments (BoP, current US$) in Maldives?
Your answer should be compact. 1.21e+12. In the year 2011, what is the difference between the Payments (BoP, current US$) in Middle East & North Africa (all income levels) and Payments (BoP, current US$) in Yemen, Rep.?
Your response must be concise. 1.20e+12. In the year 2011, what is the difference between the Payments (BoP, current US$) in Ghana and Payments (BoP, current US$) in Maldives?
Your response must be concise. 1.82e+1. In the year 2011, what is the difference between the Payments (BoP, current US$) of Ghana and Payments (BoP, current US$) of Yemen, Rep.?
Provide a short and direct response. 7.71e+09. In the year 2011, what is the difference between the Payments (BoP, current US$) of Maldives and Payments (BoP, current US$) of Yemen, Rep.?
Your response must be concise. -1.05e+1. In the year 2012, what is the difference between the Payments (BoP, current US$) in Middle East & North Africa (all income levels) and Payments (BoP, current US$) in Ghana?
Offer a terse response. 1.30e+12. In the year 2012, what is the difference between the Payments (BoP, current US$) of Middle East & North Africa (all income levels) and Payments (BoP, current US$) of Maldives?
Ensure brevity in your answer.  1.33e+12. In the year 2012, what is the difference between the Payments (BoP, current US$) of Middle East & North Africa (all income levels) and Payments (BoP, current US$) of Yemen, Rep.?
Your answer should be very brief. 1.31e+12. In the year 2012, what is the difference between the Payments (BoP, current US$) of Ghana and Payments (BoP, current US$) of Maldives?
Offer a terse response. 2.18e+1. In the year 2012, what is the difference between the Payments (BoP, current US$) of Ghana and Payments (BoP, current US$) of Yemen, Rep.?
Offer a very short reply. 8.98e+09. In the year 2012, what is the difference between the Payments (BoP, current US$) of Maldives and Payments (BoP, current US$) of Yemen, Rep.?
Provide a succinct answer. -1.28e+1. In the year 2013, what is the difference between the Payments (BoP, current US$) of Middle East & North Africa (all income levels) and Payments (BoP, current US$) of Ghana?
Make the answer very short. 1.36e+12. In the year 2013, what is the difference between the Payments (BoP, current US$) in Middle East & North Africa (all income levels) and Payments (BoP, current US$) in Maldives?
Ensure brevity in your answer.  1.38e+12. In the year 2013, what is the difference between the Payments (BoP, current US$) in Middle East & North Africa (all income levels) and Payments (BoP, current US$) in Yemen, Rep.?
Provide a short and direct response. 1.37e+12. In the year 2013, what is the difference between the Payments (BoP, current US$) in Ghana and Payments (BoP, current US$) in Maldives?
Provide a short and direct response. 2.14e+1. In the year 2013, what is the difference between the Payments (BoP, current US$) of Ghana and Payments (BoP, current US$) of Yemen, Rep.?
Offer a very short reply. 9.39e+09. In the year 2013, what is the difference between the Payments (BoP, current US$) of Maldives and Payments (BoP, current US$) of Yemen, Rep.?
Your answer should be very brief. -1.20e+1. What is the ratio of the Payments (BoP, current US$) in Middle East & North Africa (all income levels) in 2007 to that in 2008?
Provide a short and direct response. 0.79. What is the ratio of the Payments (BoP, current US$) in Ghana in 2007 to that in 2008?
Make the answer very short. 0.83. What is the ratio of the Payments (BoP, current US$) of Maldives in 2007 to that in 2008?
Give a very brief answer. 0.82. What is the ratio of the Payments (BoP, current US$) in Yemen, Rep. in 2007 to that in 2008?
Make the answer very short. 0.8. What is the ratio of the Payments (BoP, current US$) of Middle East & North Africa (all income levels) in 2007 to that in 2009?
Your response must be concise. 0.9. What is the ratio of the Payments (BoP, current US$) of Ghana in 2007 to that in 2009?
Your answer should be very brief. 0.9. What is the ratio of the Payments (BoP, current US$) of Maldives in 2007 to that in 2009?
Your answer should be compact. 1.11. What is the ratio of the Payments (BoP, current US$) in Yemen, Rep. in 2007 to that in 2009?
Make the answer very short. 0.98. What is the ratio of the Payments (BoP, current US$) in Middle East & North Africa (all income levels) in 2007 to that in 2010?
Your answer should be compact. 0.82. What is the ratio of the Payments (BoP, current US$) in Ghana in 2007 to that in 2010?
Provide a succinct answer. 0.72. What is the ratio of the Payments (BoP, current US$) in Maldives in 2007 to that in 2010?
Give a very brief answer. 0.97. What is the ratio of the Payments (BoP, current US$) of Yemen, Rep. in 2007 to that in 2010?
Your response must be concise. 0.89. What is the ratio of the Payments (BoP, current US$) in Middle East & North Africa (all income levels) in 2007 to that in 2011?
Your answer should be compact. 0.73. What is the ratio of the Payments (BoP, current US$) in Ghana in 2007 to that in 2011?
Keep it short and to the point. 0.51. What is the ratio of the Payments (BoP, current US$) in Maldives in 2007 to that in 2011?
Give a very brief answer. 0.74. What is the ratio of the Payments (BoP, current US$) of Yemen, Rep. in 2007 to that in 2011?
Provide a succinct answer. 0.85. What is the ratio of the Payments (BoP, current US$) of Middle East & North Africa (all income levels) in 2007 to that in 2012?
Offer a very short reply. 0.67. What is the ratio of the Payments (BoP, current US$) in Ghana in 2007 to that in 2012?
Provide a short and direct response. 0.43. What is the ratio of the Payments (BoP, current US$) of Maldives in 2007 to that in 2012?
Make the answer very short. 0.8. What is the ratio of the Payments (BoP, current US$) of Yemen, Rep. in 2007 to that in 2012?
Offer a terse response. 0.73. What is the ratio of the Payments (BoP, current US$) of Middle East & North Africa (all income levels) in 2007 to that in 2013?
Provide a short and direct response. 0.64. What is the ratio of the Payments (BoP, current US$) in Ghana in 2007 to that in 2013?
Offer a terse response. 0.44. What is the ratio of the Payments (BoP, current US$) in Maldives in 2007 to that in 2013?
Offer a terse response. 0.7. What is the ratio of the Payments (BoP, current US$) of Yemen, Rep. in 2007 to that in 2013?
Ensure brevity in your answer.  0.75. What is the ratio of the Payments (BoP, current US$) of Middle East & North Africa (all income levels) in 2008 to that in 2009?
Offer a very short reply. 1.14. What is the ratio of the Payments (BoP, current US$) of Ghana in 2008 to that in 2009?
Offer a terse response. 1.08. What is the ratio of the Payments (BoP, current US$) in Maldives in 2008 to that in 2009?
Keep it short and to the point. 1.35. What is the ratio of the Payments (BoP, current US$) in Yemen, Rep. in 2008 to that in 2009?
Give a very brief answer. 1.23. What is the ratio of the Payments (BoP, current US$) of Middle East & North Africa (all income levels) in 2008 to that in 2010?
Keep it short and to the point. 1.04. What is the ratio of the Payments (BoP, current US$) in Ghana in 2008 to that in 2010?
Keep it short and to the point. 0.87. What is the ratio of the Payments (BoP, current US$) in Maldives in 2008 to that in 2010?
Make the answer very short. 1.19. What is the ratio of the Payments (BoP, current US$) of Yemen, Rep. in 2008 to that in 2010?
Make the answer very short. 1.11. What is the ratio of the Payments (BoP, current US$) in Middle East & North Africa (all income levels) in 2008 to that in 2011?
Your answer should be compact. 0.93. What is the ratio of the Payments (BoP, current US$) of Ghana in 2008 to that in 2011?
Your response must be concise. 0.61. What is the ratio of the Payments (BoP, current US$) in Maldives in 2008 to that in 2011?
Provide a succinct answer. 0.91. What is the ratio of the Payments (BoP, current US$) of Yemen, Rep. in 2008 to that in 2011?
Keep it short and to the point. 1.06. What is the ratio of the Payments (BoP, current US$) of Middle East & North Africa (all income levels) in 2008 to that in 2012?
Your answer should be compact. 0.85. What is the ratio of the Payments (BoP, current US$) of Ghana in 2008 to that in 2012?
Your answer should be compact. 0.52. What is the ratio of the Payments (BoP, current US$) in Maldives in 2008 to that in 2012?
Offer a very short reply. 0.98. What is the ratio of the Payments (BoP, current US$) of Yemen, Rep. in 2008 to that in 2012?
Your answer should be very brief. 0.92. What is the ratio of the Payments (BoP, current US$) of Middle East & North Africa (all income levels) in 2008 to that in 2013?
Provide a short and direct response. 0.81. What is the ratio of the Payments (BoP, current US$) in Ghana in 2008 to that in 2013?
Your response must be concise. 0.53. What is the ratio of the Payments (BoP, current US$) in Maldives in 2008 to that in 2013?
Offer a very short reply. 0.86. What is the ratio of the Payments (BoP, current US$) in Yemen, Rep. in 2008 to that in 2013?
Your answer should be compact. 0.94. What is the ratio of the Payments (BoP, current US$) in Middle East & North Africa (all income levels) in 2009 to that in 2010?
Provide a succinct answer. 0.91. What is the ratio of the Payments (BoP, current US$) in Ghana in 2009 to that in 2010?
Your answer should be very brief. 0.8. What is the ratio of the Payments (BoP, current US$) of Maldives in 2009 to that in 2010?
Offer a very short reply. 0.88. What is the ratio of the Payments (BoP, current US$) in Yemen, Rep. in 2009 to that in 2010?
Give a very brief answer. 0.9. What is the ratio of the Payments (BoP, current US$) of Middle East & North Africa (all income levels) in 2009 to that in 2011?
Make the answer very short. 0.82. What is the ratio of the Payments (BoP, current US$) in Ghana in 2009 to that in 2011?
Make the answer very short. 0.56. What is the ratio of the Payments (BoP, current US$) in Maldives in 2009 to that in 2011?
Give a very brief answer. 0.67. What is the ratio of the Payments (BoP, current US$) in Yemen, Rep. in 2009 to that in 2011?
Provide a short and direct response. 0.86. What is the ratio of the Payments (BoP, current US$) of Middle East & North Africa (all income levels) in 2009 to that in 2012?
Keep it short and to the point. 0.74. What is the ratio of the Payments (BoP, current US$) in Ghana in 2009 to that in 2012?
Your answer should be compact. 0.48. What is the ratio of the Payments (BoP, current US$) in Maldives in 2009 to that in 2012?
Keep it short and to the point. 0.72. What is the ratio of the Payments (BoP, current US$) of Yemen, Rep. in 2009 to that in 2012?
Give a very brief answer. 0.74. What is the ratio of the Payments (BoP, current US$) of Ghana in 2009 to that in 2013?
Give a very brief answer. 0.49. What is the ratio of the Payments (BoP, current US$) in Maldives in 2009 to that in 2013?
Provide a succinct answer. 0.64. What is the ratio of the Payments (BoP, current US$) of Yemen, Rep. in 2009 to that in 2013?
Keep it short and to the point. 0.76. What is the ratio of the Payments (BoP, current US$) in Middle East & North Africa (all income levels) in 2010 to that in 2011?
Your answer should be compact. 0.9. What is the ratio of the Payments (BoP, current US$) in Ghana in 2010 to that in 2011?
Provide a succinct answer. 0.7. What is the ratio of the Payments (BoP, current US$) in Maldives in 2010 to that in 2011?
Offer a very short reply. 0.77. What is the ratio of the Payments (BoP, current US$) of Yemen, Rep. in 2010 to that in 2011?
Offer a very short reply. 0.95. What is the ratio of the Payments (BoP, current US$) in Middle East & North Africa (all income levels) in 2010 to that in 2012?
Make the answer very short. 0.81. What is the ratio of the Payments (BoP, current US$) of Ghana in 2010 to that in 2012?
Keep it short and to the point. 0.6. What is the ratio of the Payments (BoP, current US$) in Maldives in 2010 to that in 2012?
Your answer should be very brief. 0.83. What is the ratio of the Payments (BoP, current US$) of Yemen, Rep. in 2010 to that in 2012?
Your answer should be very brief. 0.82. What is the ratio of the Payments (BoP, current US$) of Middle East & North Africa (all income levels) in 2010 to that in 2013?
Make the answer very short. 0.78. What is the ratio of the Payments (BoP, current US$) of Ghana in 2010 to that in 2013?
Make the answer very short. 0.6. What is the ratio of the Payments (BoP, current US$) in Maldives in 2010 to that in 2013?
Your answer should be very brief. 0.73. What is the ratio of the Payments (BoP, current US$) of Yemen, Rep. in 2010 to that in 2013?
Ensure brevity in your answer.  0.85. What is the ratio of the Payments (BoP, current US$) in Middle East & North Africa (all income levels) in 2011 to that in 2012?
Offer a terse response. 0.91. What is the ratio of the Payments (BoP, current US$) of Ghana in 2011 to that in 2012?
Offer a terse response. 0.86. What is the ratio of the Payments (BoP, current US$) of Maldives in 2011 to that in 2012?
Ensure brevity in your answer.  1.07. What is the ratio of the Payments (BoP, current US$) of Yemen, Rep. in 2011 to that in 2012?
Your answer should be compact. 0.86. What is the ratio of the Payments (BoP, current US$) of Middle East & North Africa (all income levels) in 2011 to that in 2013?
Give a very brief answer. 0.87. What is the ratio of the Payments (BoP, current US$) in Ghana in 2011 to that in 2013?
Offer a very short reply. 0.86. What is the ratio of the Payments (BoP, current US$) of Maldives in 2011 to that in 2013?
Provide a short and direct response. 0.94. What is the ratio of the Payments (BoP, current US$) of Yemen, Rep. in 2011 to that in 2013?
Make the answer very short. 0.89. What is the ratio of the Payments (BoP, current US$) in Middle East & North Africa (all income levels) in 2012 to that in 2013?
Provide a short and direct response. 0.96. What is the ratio of the Payments (BoP, current US$) of Maldives in 2012 to that in 2013?
Keep it short and to the point. 0.88. What is the ratio of the Payments (BoP, current US$) of Yemen, Rep. in 2012 to that in 2013?
Give a very brief answer. 1.03. What is the difference between the highest and the second highest Payments (BoP, current US$) in Middle East & North Africa (all income levels)?
Offer a very short reply. 5.67e+1. What is the difference between the highest and the second highest Payments (BoP, current US$) in Ghana?
Offer a very short reply. 5.29e+07. What is the difference between the highest and the second highest Payments (BoP, current US$) in Maldives?
Give a very brief answer. 1.57e+08. What is the difference between the highest and the second highest Payments (BoP, current US$) of Yemen, Rep.?
Provide a short and direct response. 4.59e+08. What is the difference between the highest and the lowest Payments (BoP, current US$) of Middle East & North Africa (all income levels)?
Your response must be concise. 4.99e+11. What is the difference between the highest and the lowest Payments (BoP, current US$) of Ghana?
Your answer should be very brief. 1.37e+1. What is the difference between the highest and the lowest Payments (BoP, current US$) of Maldives?
Make the answer very short. 1.01e+09. What is the difference between the highest and the lowest Payments (BoP, current US$) in Yemen, Rep.?
Keep it short and to the point. 4.11e+09. 